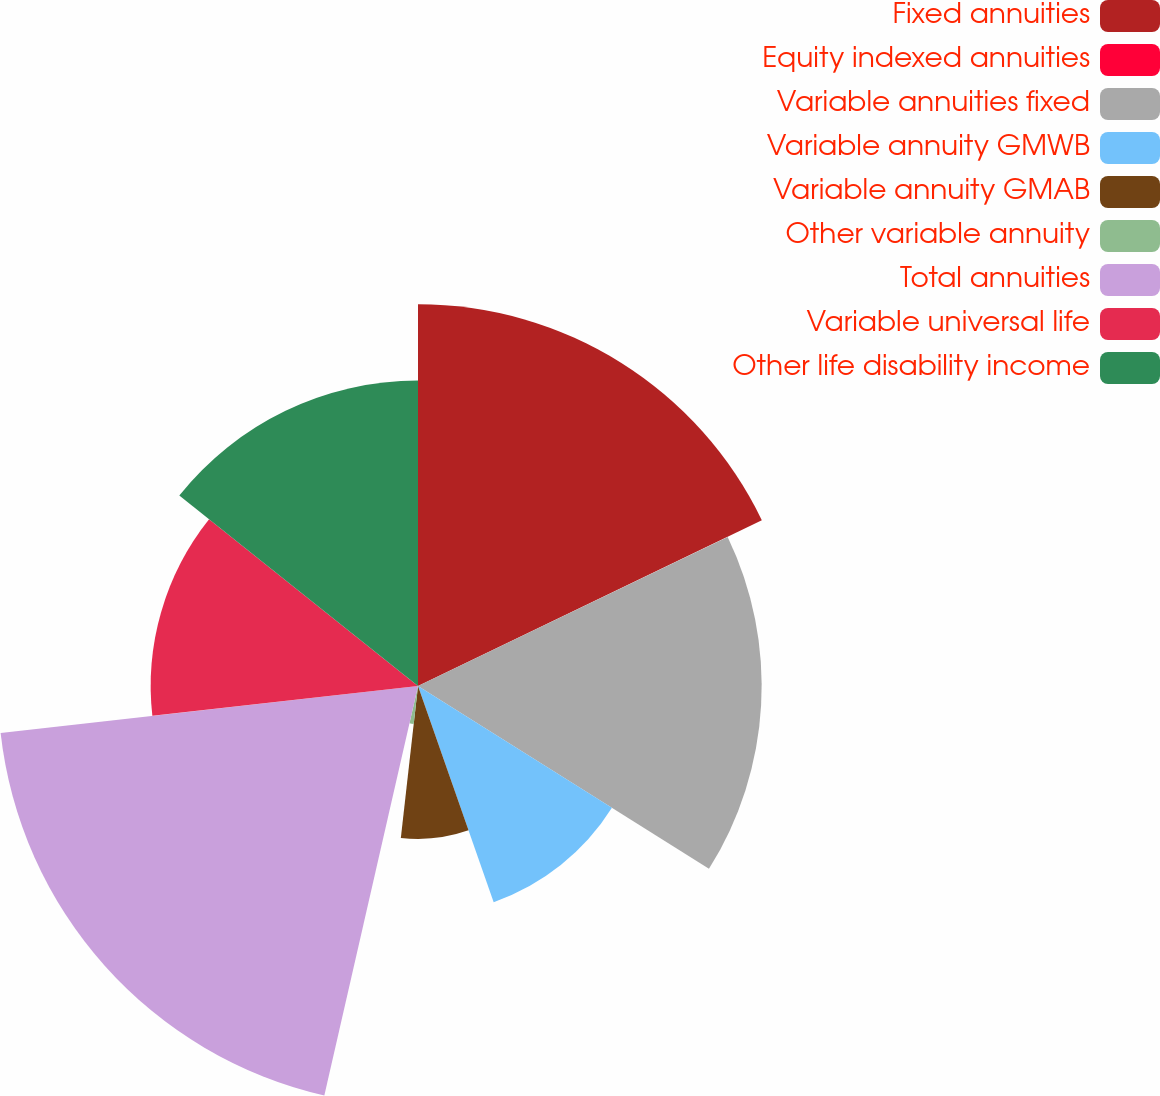<chart> <loc_0><loc_0><loc_500><loc_500><pie_chart><fcel>Fixed annuities<fcel>Equity indexed annuities<fcel>Variable annuities fixed<fcel>Variable annuity GMWB<fcel>Variable annuity GMAB<fcel>Other variable annuity<fcel>Total annuities<fcel>Variable universal life<fcel>Other life disability income<nl><fcel>17.85%<fcel>0.01%<fcel>16.07%<fcel>10.71%<fcel>7.15%<fcel>1.79%<fcel>19.64%<fcel>12.5%<fcel>14.28%<nl></chart> 